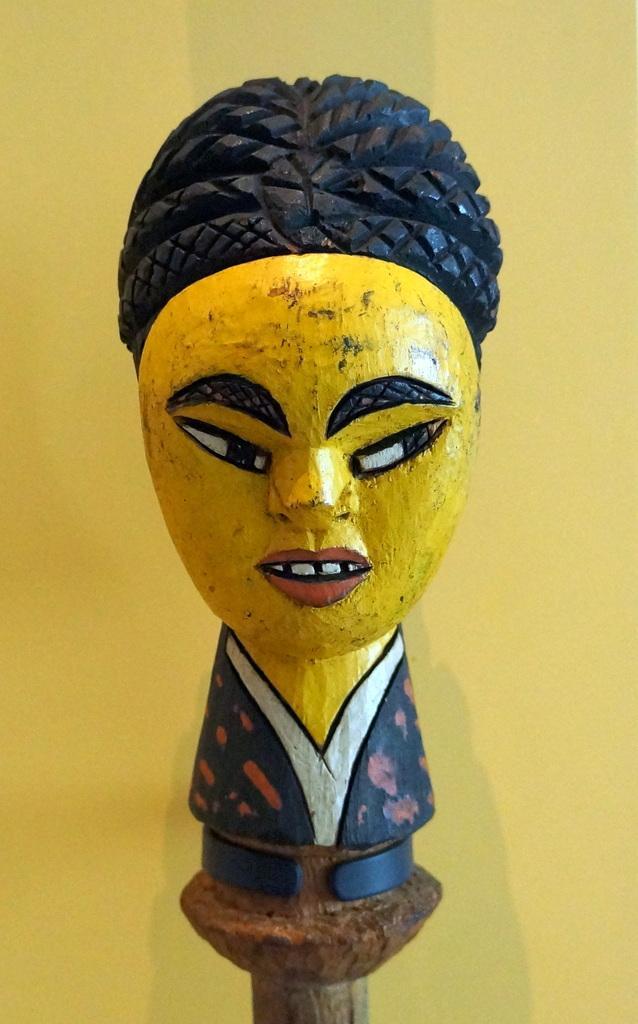Describe this image in one or two sentences. In this picture we can see a toy. Behind the toy, there is the yellow background. 